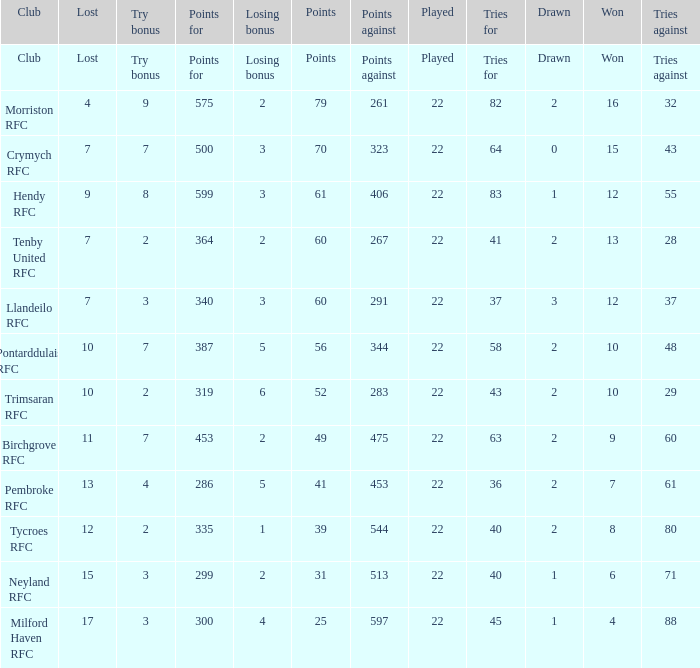What's the won with points against being 597 4.0. 